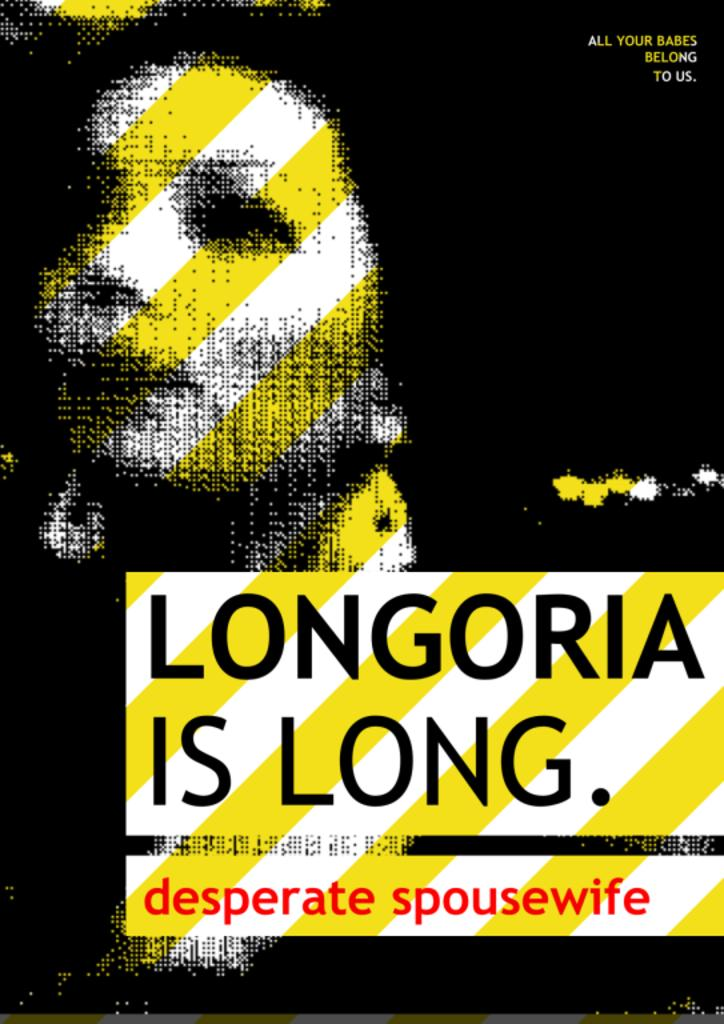Provide a one-sentence caption for the provided image. A satire poster about a desperate spousewife named Longoria. 